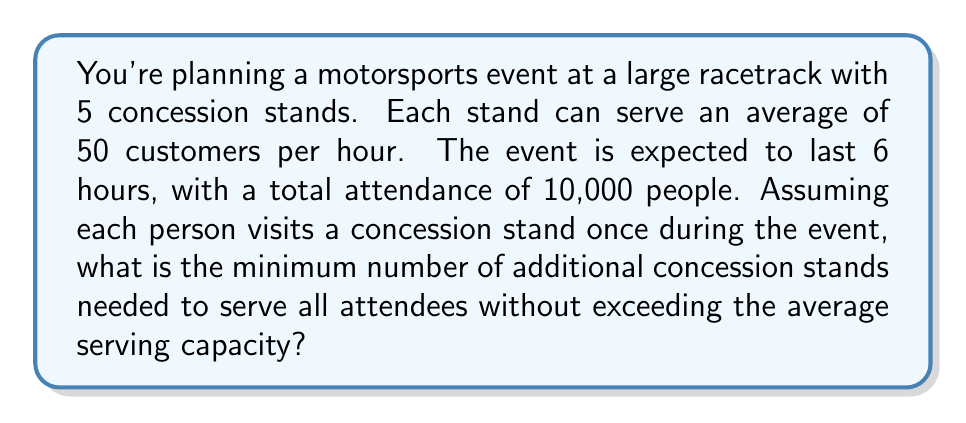Can you answer this question? Let's approach this step-by-step:

1. Calculate the total serving capacity of the existing stands:
   - Number of existing stands: 5
   - Serving capacity per stand per hour: 50
   - Event duration: 6 hours
   
   Total capacity = $5 \times 50 \times 6 = 1500$ customers

2. Calculate the number of customers that need to be served:
   - Total attendance: 10,000
   - Assuming each person visits once: 10,000 customers need to be served

3. Calculate the additional customers that need to be served:
   Additional customers = $10,000 - 1500 = 8500$

4. Calculate the number of additional stands needed:
   Let $x$ be the number of additional stands.
   
   Each additional stand can serve: $50 \times 6 = 300$ customers over the event duration.
   
   We need to solve the inequality:
   
   $$ 300x \geq 8500 $$
   
   $$ x \geq \frac{8500}{300} \approx 28.33 $$

5. Since we can't have a fractional number of stands, we round up to the nearest whole number.
Answer: The minimum number of additional concession stands needed is 29. 